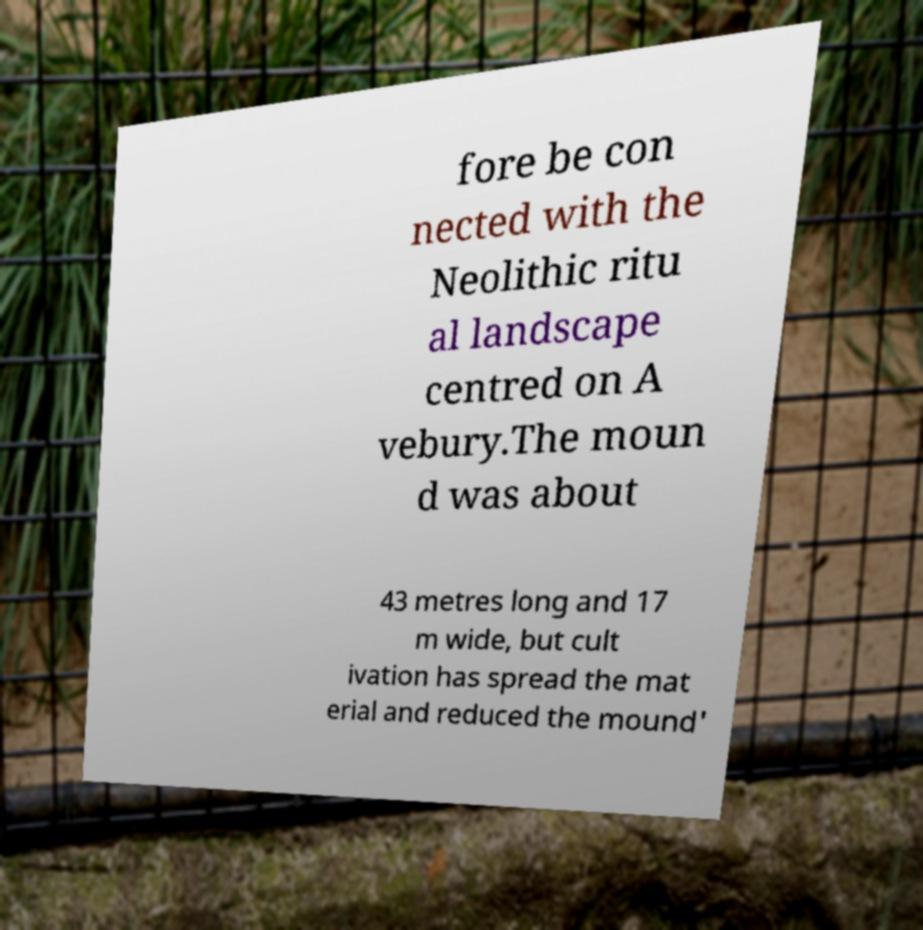Could you extract and type out the text from this image? fore be con nected with the Neolithic ritu al landscape centred on A vebury.The moun d was about 43 metres long and 17 m wide, but cult ivation has spread the mat erial and reduced the mound' 